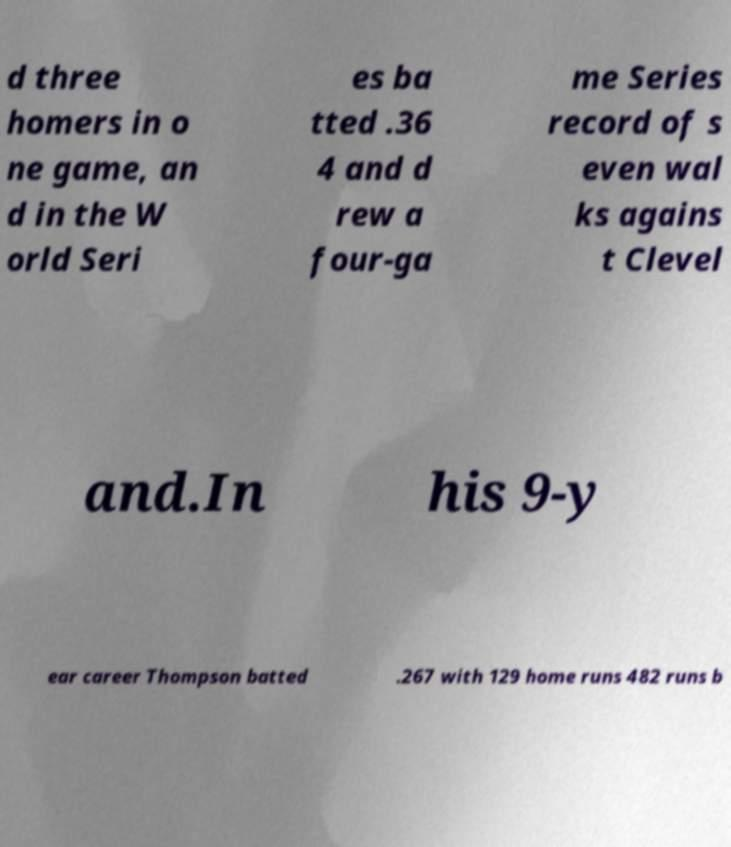Can you accurately transcribe the text from the provided image for me? d three homers in o ne game, an d in the W orld Seri es ba tted .36 4 and d rew a four-ga me Series record of s even wal ks agains t Clevel and.In his 9-y ear career Thompson batted .267 with 129 home runs 482 runs b 